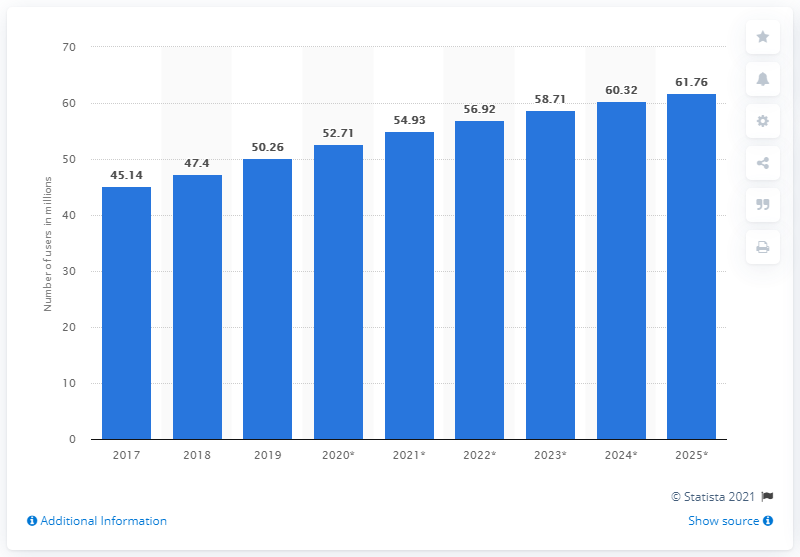Identify some key points in this picture. By 2025, an estimated 61.76% of the population in Thailand will be social network users. 